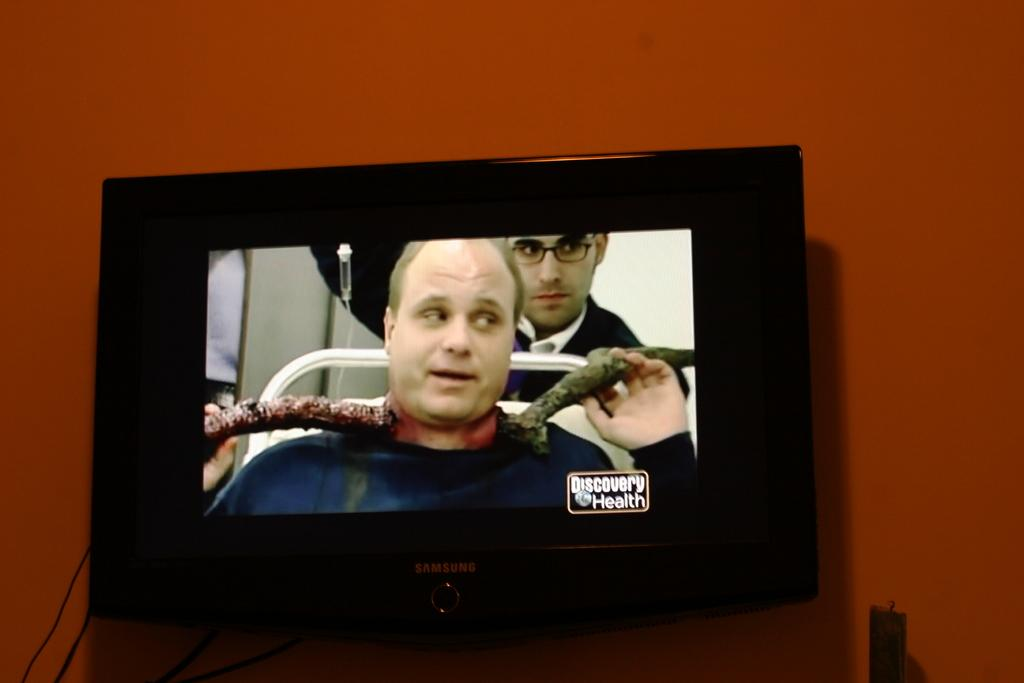<image>
Offer a succinct explanation of the picture presented. A screen shows a medical show on the Discovery Health channel. 